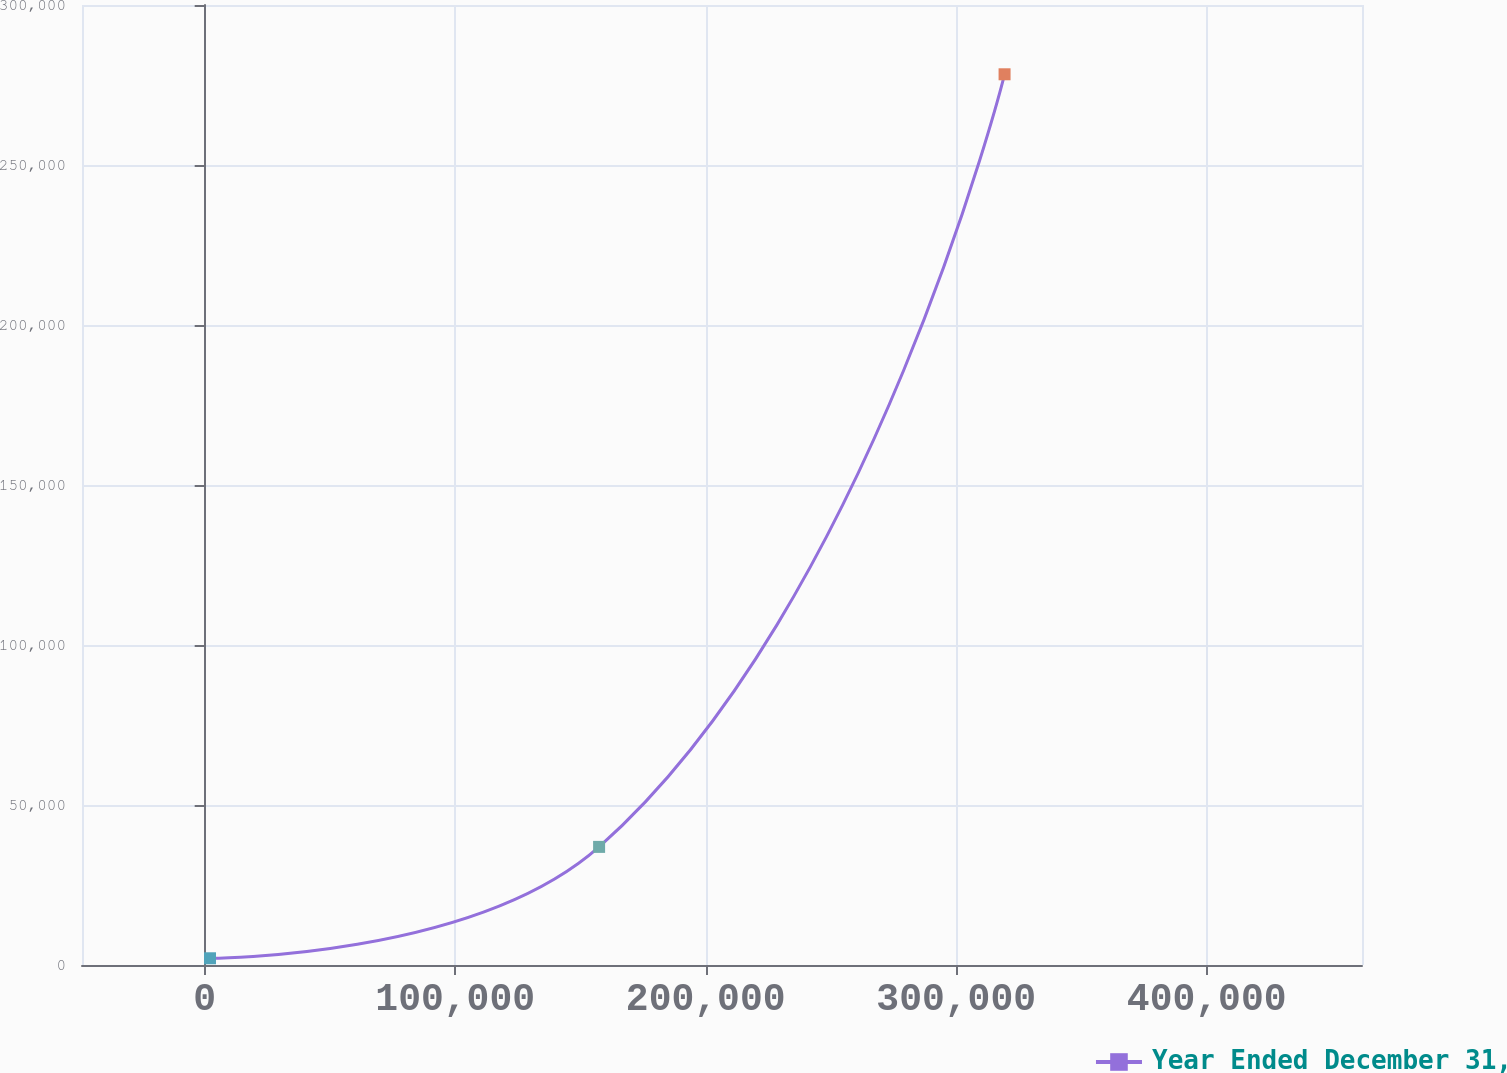Convert chart to OTSL. <chart><loc_0><loc_0><loc_500><loc_500><line_chart><ecel><fcel>Year Ended December 31,<nl><fcel>2120.56<fcel>2101.82<nl><fcel>157452<fcel>36911.8<nl><fcel>319317<fcel>278350<nl><fcel>513106<fcel>350201<nl></chart> 